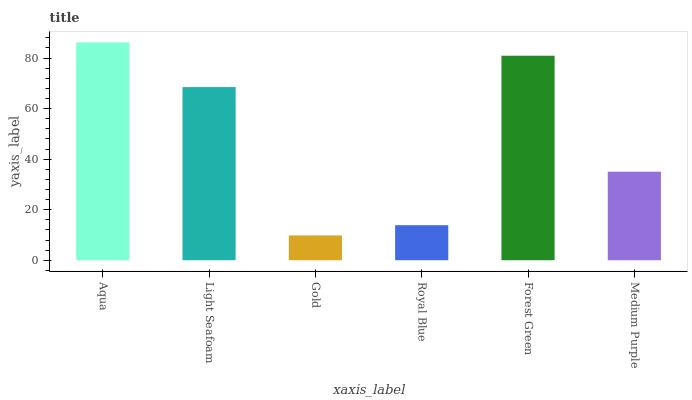Is Gold the minimum?
Answer yes or no. Yes. Is Aqua the maximum?
Answer yes or no. Yes. Is Light Seafoam the minimum?
Answer yes or no. No. Is Light Seafoam the maximum?
Answer yes or no. No. Is Aqua greater than Light Seafoam?
Answer yes or no. Yes. Is Light Seafoam less than Aqua?
Answer yes or no. Yes. Is Light Seafoam greater than Aqua?
Answer yes or no. No. Is Aqua less than Light Seafoam?
Answer yes or no. No. Is Light Seafoam the high median?
Answer yes or no. Yes. Is Medium Purple the low median?
Answer yes or no. Yes. Is Forest Green the high median?
Answer yes or no. No. Is Gold the low median?
Answer yes or no. No. 